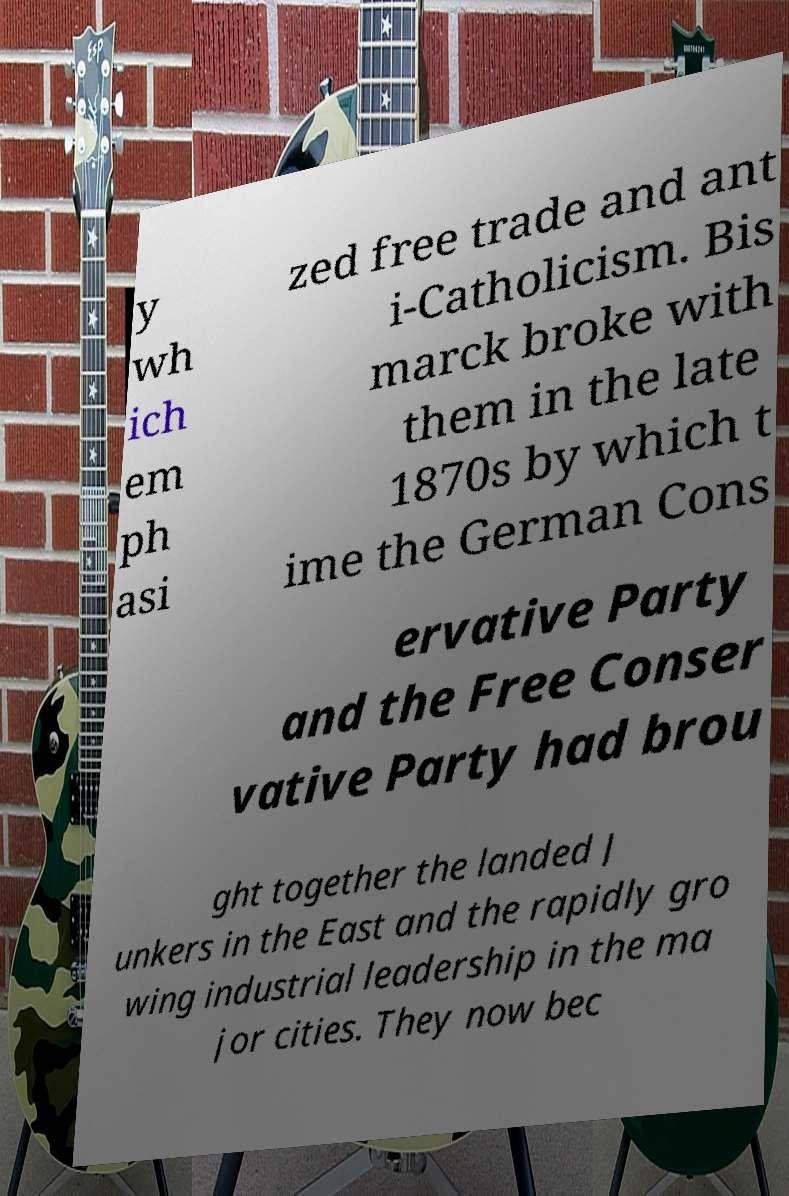What messages or text are displayed in this image? I need them in a readable, typed format. y wh ich em ph asi zed free trade and ant i-Catholicism. Bis marck broke with them in the late 1870s by which t ime the German Cons ervative Party and the Free Conser vative Party had brou ght together the landed J unkers in the East and the rapidly gro wing industrial leadership in the ma jor cities. They now bec 